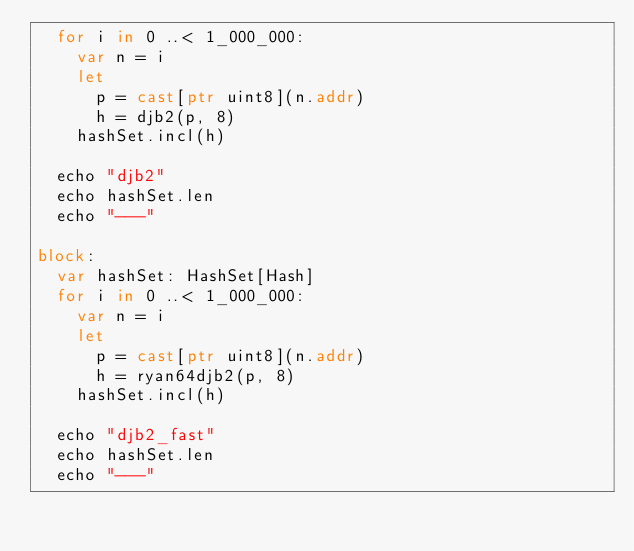<code> <loc_0><loc_0><loc_500><loc_500><_Nim_>  for i in 0 ..< 1_000_000:
    var n = i
    let
      p = cast[ptr uint8](n.addr)
      h = djb2(p, 8)
    hashSet.incl(h)

  echo "djb2"
  echo hashSet.len
  echo "---"

block:
  var hashSet: HashSet[Hash]
  for i in 0 ..< 1_000_000:
    var n = i
    let
      p = cast[ptr uint8](n.addr)
      h = ryan64djb2(p, 8)
    hashSet.incl(h)

  echo "djb2_fast"
  echo hashSet.len
  echo "---"
</code> 